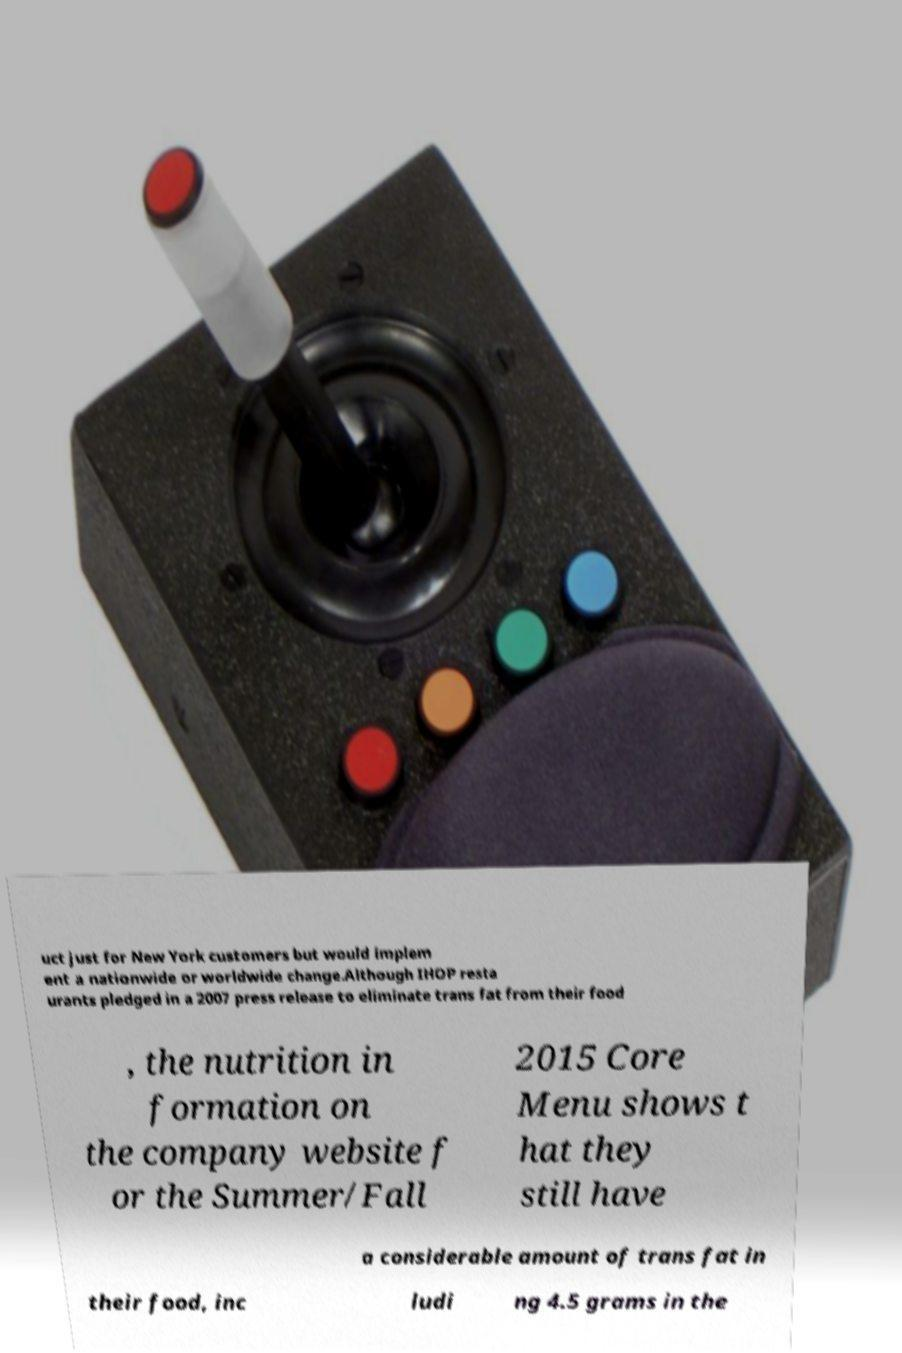For documentation purposes, I need the text within this image transcribed. Could you provide that? uct just for New York customers but would implem ent a nationwide or worldwide change.Although IHOP resta urants pledged in a 2007 press release to eliminate trans fat from their food , the nutrition in formation on the company website f or the Summer/Fall 2015 Core Menu shows t hat they still have a considerable amount of trans fat in their food, inc ludi ng 4.5 grams in the 